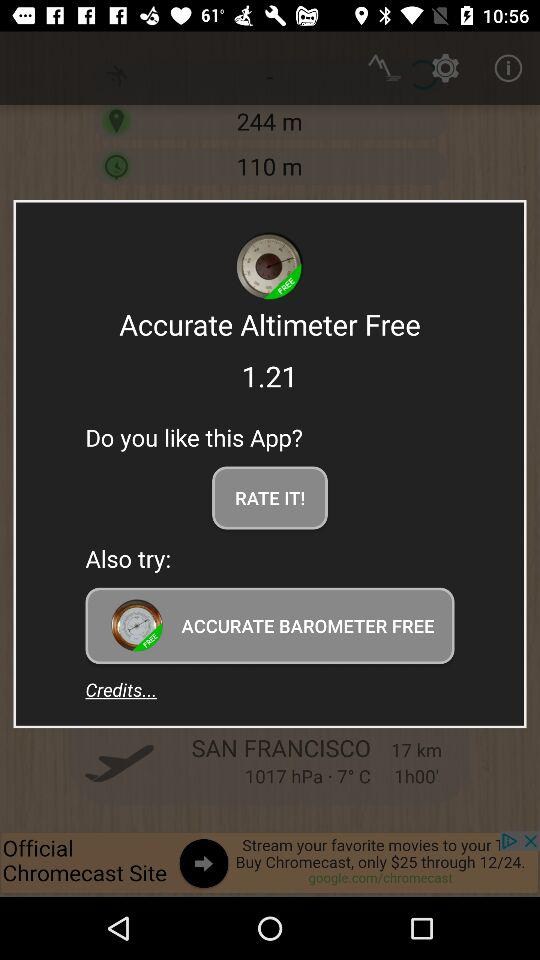How many free apps are offered?
Answer the question using a single word or phrase. 2 